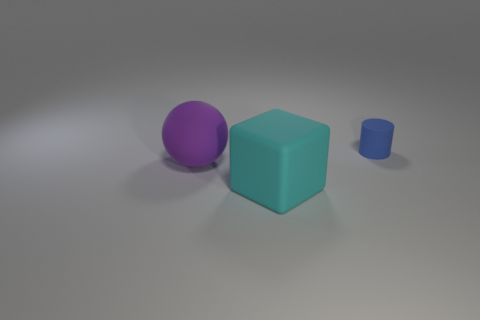Add 3 tiny blue things. How many objects exist? 6 Subtract all spheres. How many objects are left? 2 Add 2 tiny things. How many tiny things exist? 3 Subtract 1 cyan blocks. How many objects are left? 2 Subtract all gray balls. How many gray cylinders are left? 0 Subtract all green metal spheres. Subtract all blue things. How many objects are left? 2 Add 3 large purple rubber balls. How many large purple rubber balls are left? 4 